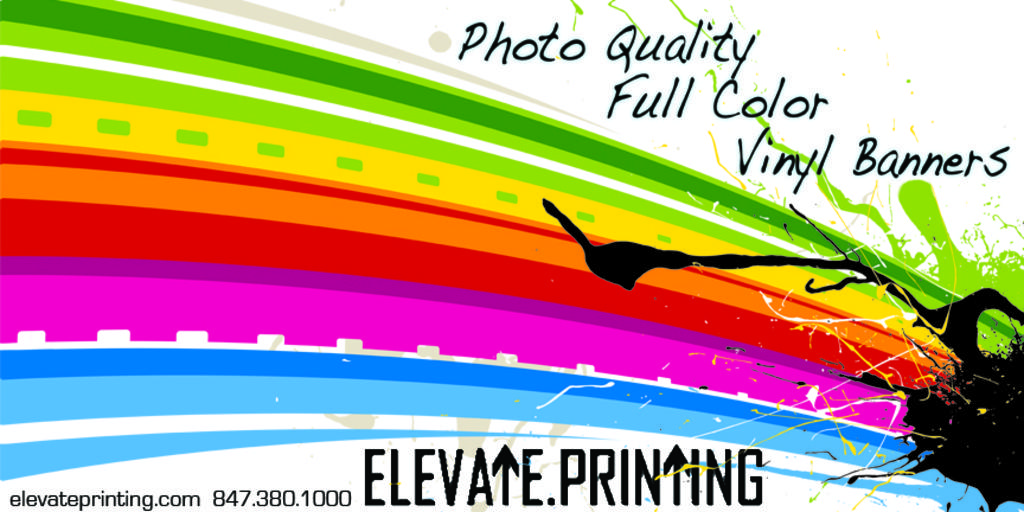What website is listed on this business card?
Offer a terse response. Elevateprinting.com. What kind of banners do they make?
Offer a terse response. Vinyl. 